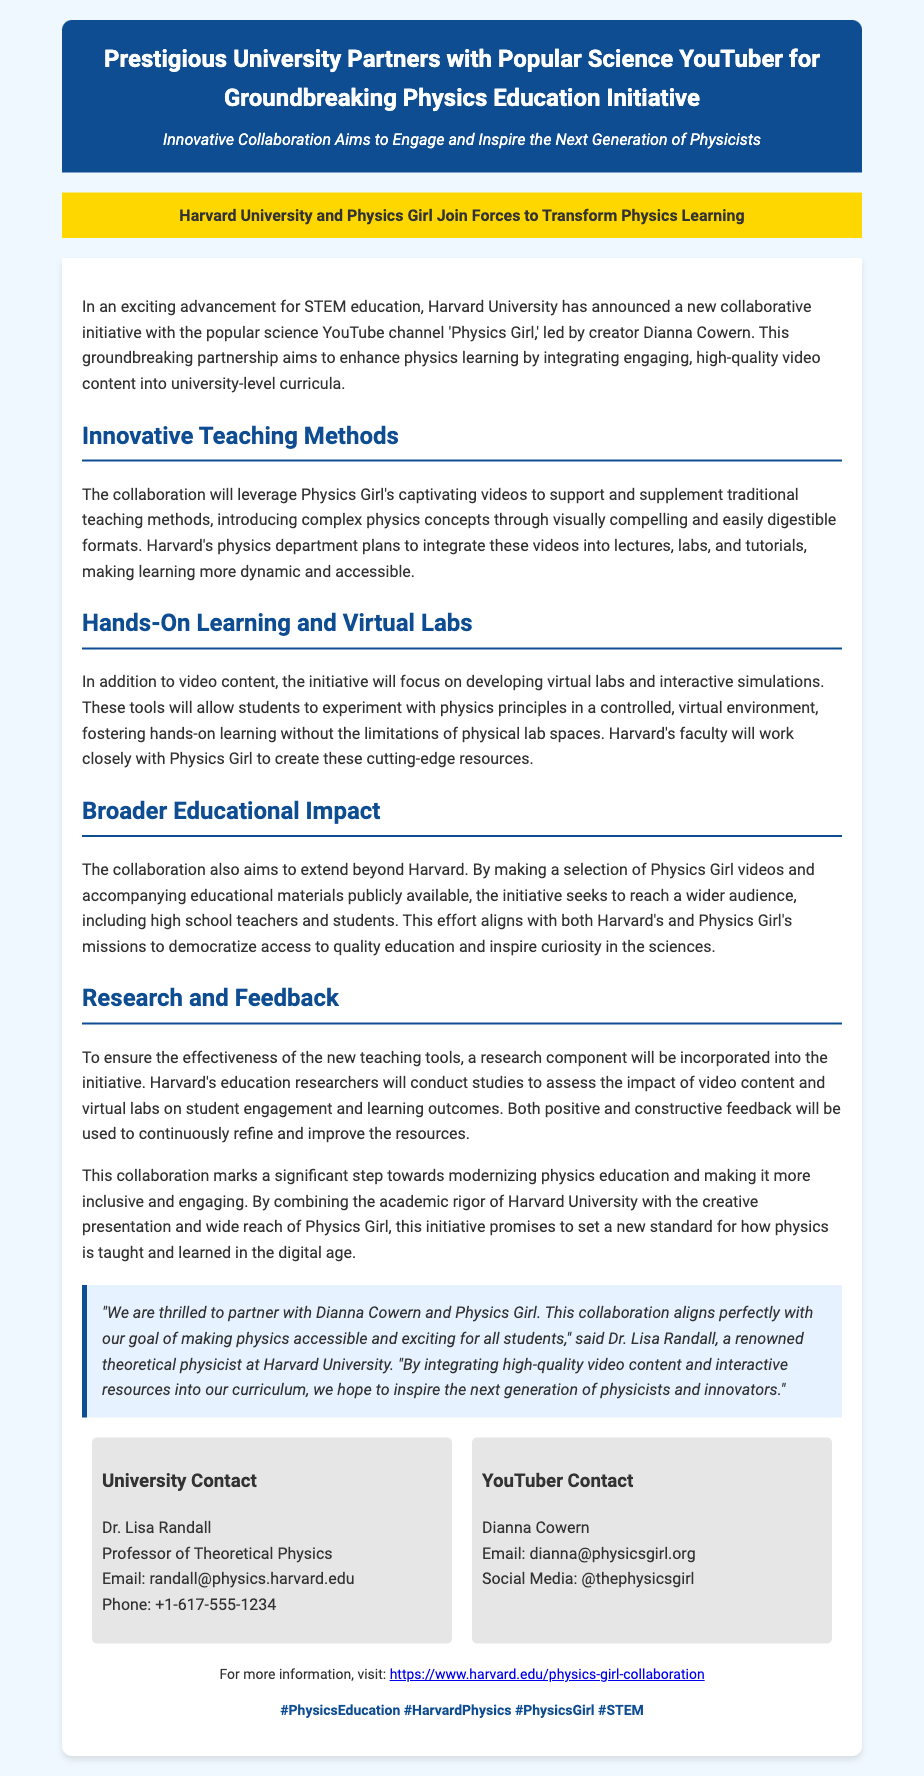What is the name of the YouTuber involved in the collaboration? The document states that the YouTuber involved is 'Physics Girl', led by creator Dianna Cowern.
Answer: Physics Girl What is the primary aim of the collaboration? The document mentions that the aim is to enhance physics learning by integrating engaging, high-quality video content into university-level curricula.
Answer: Enhance physics learning Who is the theoretical physicist quoted in the press release? The press release includes a quote from Dr. Lisa Randall, who is mentioned as a renowned theoretical physicist at Harvard University.
Answer: Dr. Lisa Randall What type of resources will be developed for student learning? The initiative will focus on developing virtual labs and interactive simulations to enhance hands-on learning.
Answer: Virtual labs and interactive simulations How will the initiative impact audiences beyond Harvard? The document explains that selected Physics Girl videos and educational materials will be made publicly available to reach a wider audience, including high school teachers and students.
Answer: Wider audience, high school teachers and students What is the URL for more information about the collaboration? The press release provides a specific URL for more information regarding the collaboration between Harvard and Physics Girl.
Answer: https://www.harvard.edu/physics-girl-collaboration What component will ensure the effectiveness of the new teaching tools? The initiative incorporates a research component to assess the impact of the video content and virtual labs on student engagement and learning outcomes.
Answer: Research component What is the theme used in the document's hashtags? The hashtags at the end of the document emphasize the topics related to the collaboration focusing on physics education and STEM.
Answer: PhysicsEducation, HarvardPhysics, PhysicsGirl, STEM 